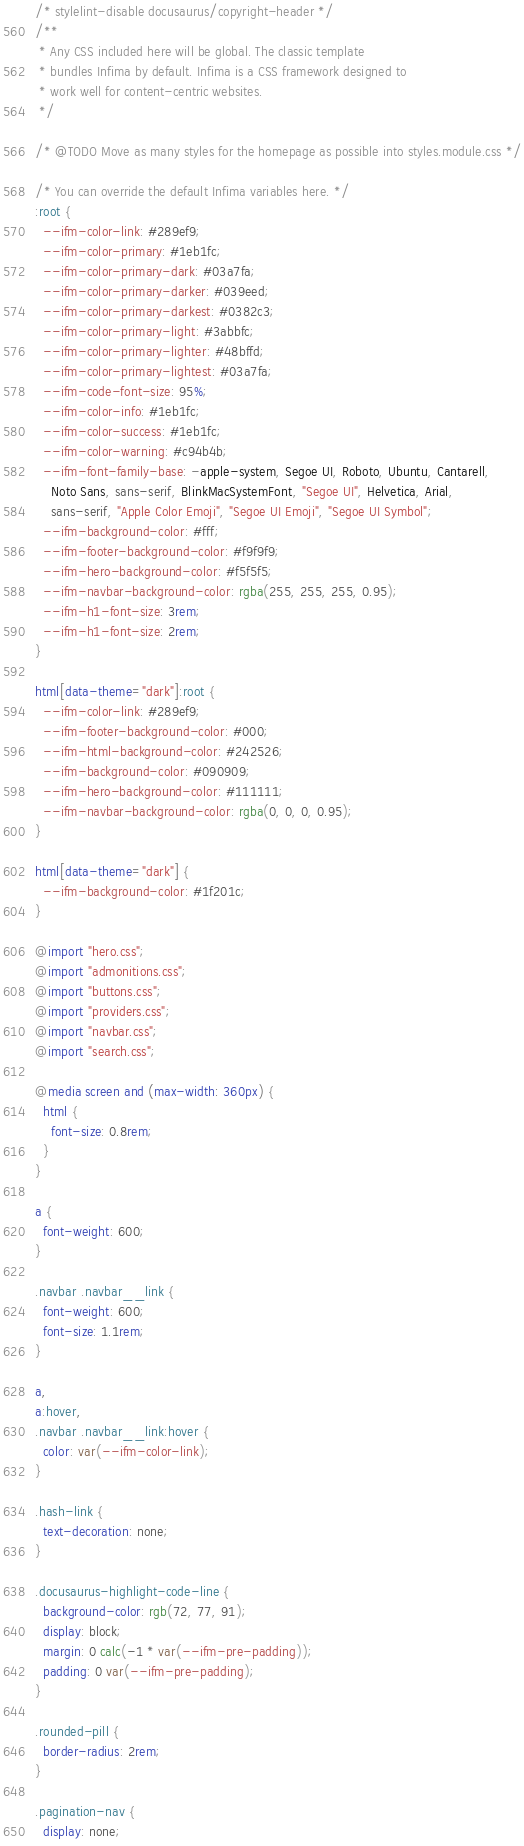<code> <loc_0><loc_0><loc_500><loc_500><_CSS_>/* stylelint-disable docusaurus/copyright-header */
/**
 * Any CSS included here will be global. The classic template
 * bundles Infima by default. Infima is a CSS framework designed to
 * work well for content-centric websites.
 */

/* @TODO Move as many styles for the homepage as possible into styles.module.css */

/* You can override the default Infima variables here. */
:root {
  --ifm-color-link: #289ef9;
  --ifm-color-primary: #1eb1fc;
  --ifm-color-primary-dark: #03a7fa;
  --ifm-color-primary-darker: #039eed;
  --ifm-color-primary-darkest: #0382c3;
  --ifm-color-primary-light: #3abbfc;
  --ifm-color-primary-lighter: #48bffd;
  --ifm-color-primary-lightest: #03a7fa;
  --ifm-code-font-size: 95%;
  --ifm-color-info: #1eb1fc;
  --ifm-color-success: #1eb1fc;
  --ifm-color-warning: #c94b4b;
  --ifm-font-family-base: -apple-system, Segoe UI, Roboto, Ubuntu, Cantarell,
    Noto Sans, sans-serif, BlinkMacSystemFont, "Segoe UI", Helvetica, Arial,
    sans-serif, "Apple Color Emoji", "Segoe UI Emoji", "Segoe UI Symbol";
  --ifm-background-color: #fff;
  --ifm-footer-background-color: #f9f9f9;
  --ifm-hero-background-color: #f5f5f5;
  --ifm-navbar-background-color: rgba(255, 255, 255, 0.95);
  --ifm-h1-font-size: 3rem;
  --ifm-h1-font-size: 2rem;
}

html[data-theme="dark"]:root {
  --ifm-color-link: #289ef9;
  --ifm-footer-background-color: #000;
  --ifm-html-background-color: #242526;
  --ifm-background-color: #090909;
  --ifm-hero-background-color: #111111;
  --ifm-navbar-background-color: rgba(0, 0, 0, 0.95);
}

html[data-theme="dark"] {
  --ifm-background-color: #1f201c;
}

@import "hero.css";
@import "admonitions.css";
@import "buttons.css";
@import "providers.css";
@import "navbar.css";
@import "search.css";

@media screen and (max-width: 360px) {
  html {
    font-size: 0.8rem;
  }
}

a {
  font-weight: 600;
}

.navbar .navbar__link {
  font-weight: 600;
  font-size: 1.1rem;
}

a,
a:hover,
.navbar .navbar__link:hover {
  color: var(--ifm-color-link);
}

.hash-link {
  text-decoration: none;
}

.docusaurus-highlight-code-line {
  background-color: rgb(72, 77, 91);
  display: block;
  margin: 0 calc(-1 * var(--ifm-pre-padding));
  padding: 0 var(--ifm-pre-padding);
}

.rounded-pill {
  border-radius: 2rem;
}

.pagination-nav {
  display: none;</code> 